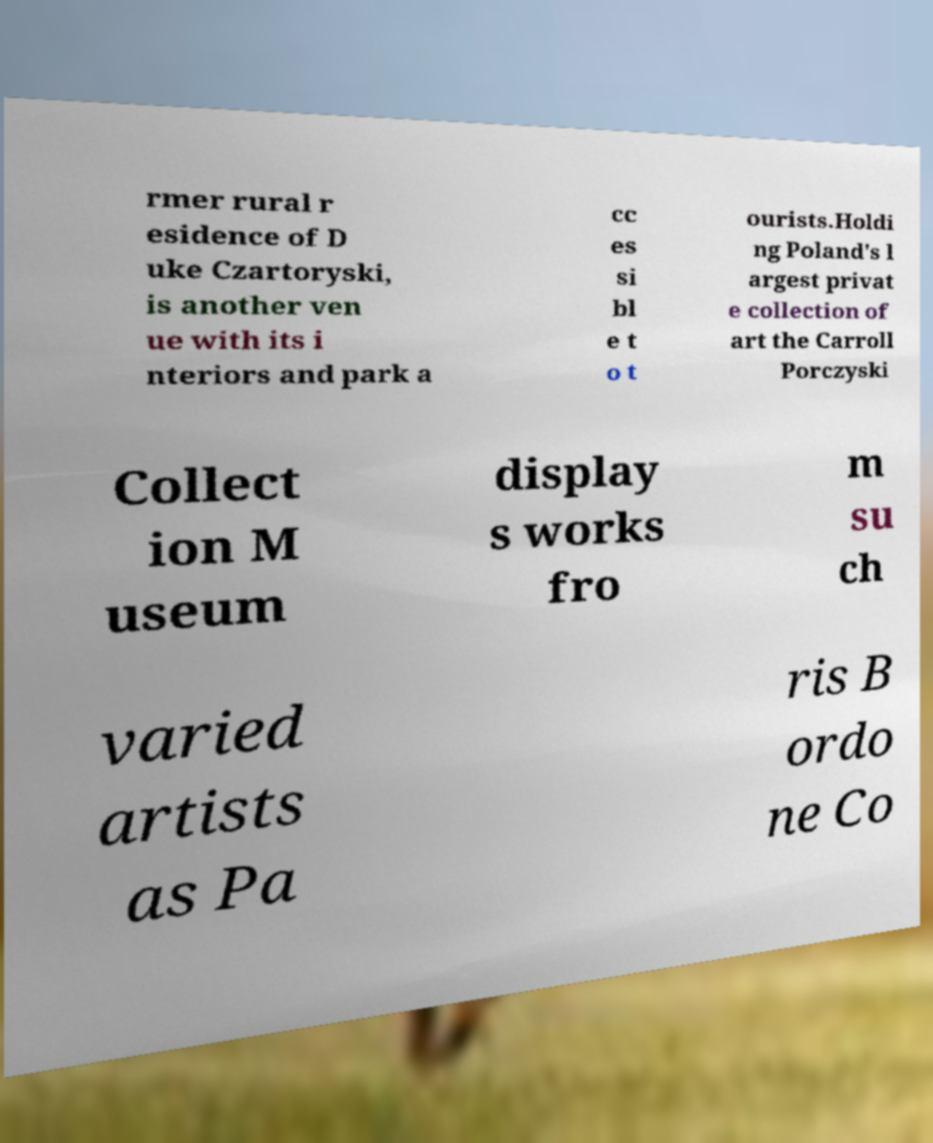Can you accurately transcribe the text from the provided image for me? rmer rural r esidence of D uke Czartoryski, is another ven ue with its i nteriors and park a cc es si bl e t o t ourists.Holdi ng Poland's l argest privat e collection of art the Carroll Porczyski Collect ion M useum display s works fro m su ch varied artists as Pa ris B ordo ne Co 